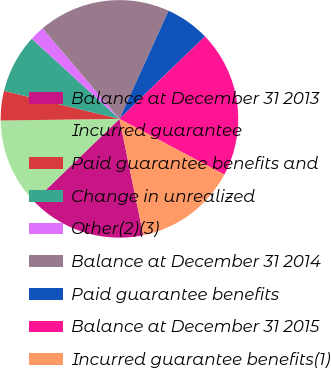Convert chart to OTSL. <chart><loc_0><loc_0><loc_500><loc_500><pie_chart><fcel>Balance at December 31 2013<fcel>Incurred guarantee<fcel>Paid guarantee benefits and<fcel>Change in unrealized<fcel>Other(2)(3)<fcel>Balance at December 31 2014<fcel>Paid guarantee benefits<fcel>Balance at December 31 2015<fcel>Incurred guarantee benefits(1)<nl><fcel>16.0%<fcel>12.0%<fcel>4.01%<fcel>8.0%<fcel>2.01%<fcel>17.99%<fcel>6.0%<fcel>19.99%<fcel>14.0%<nl></chart> 